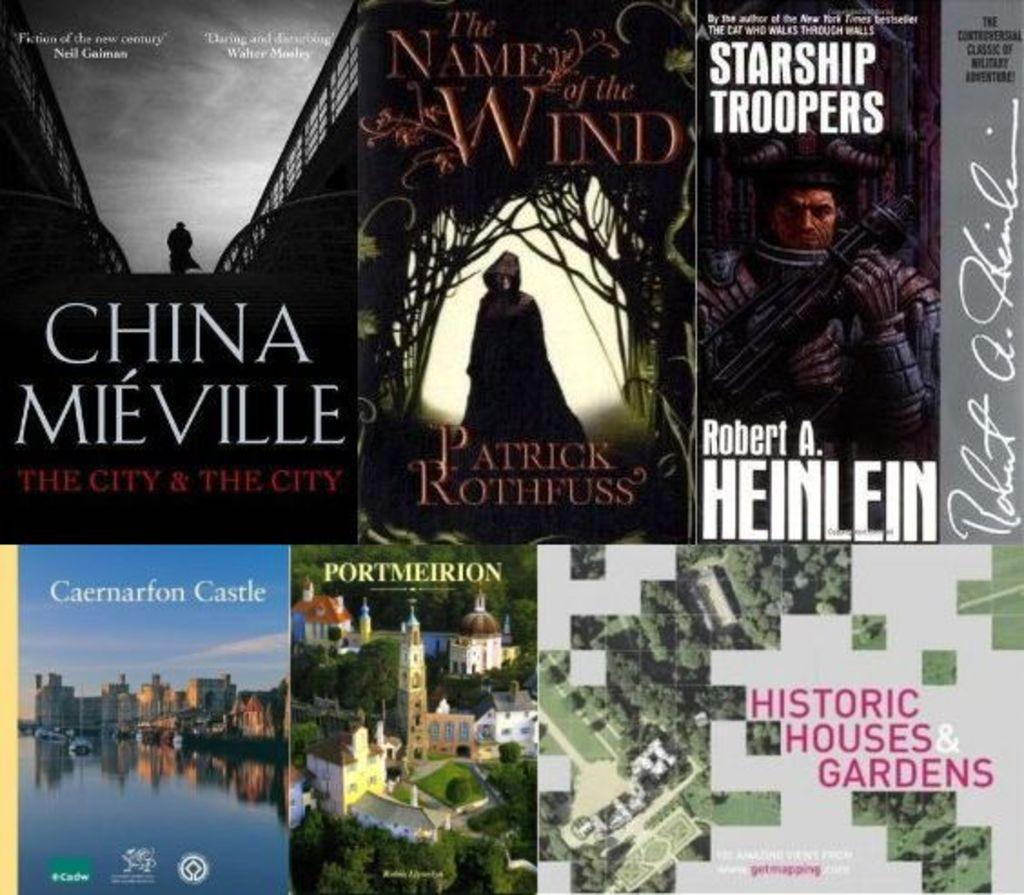Provide a one-sentence caption for the provided image. A collection of books that are all set in foreign places. 